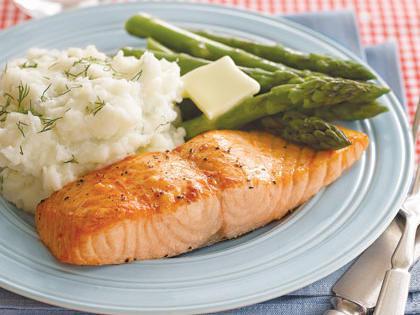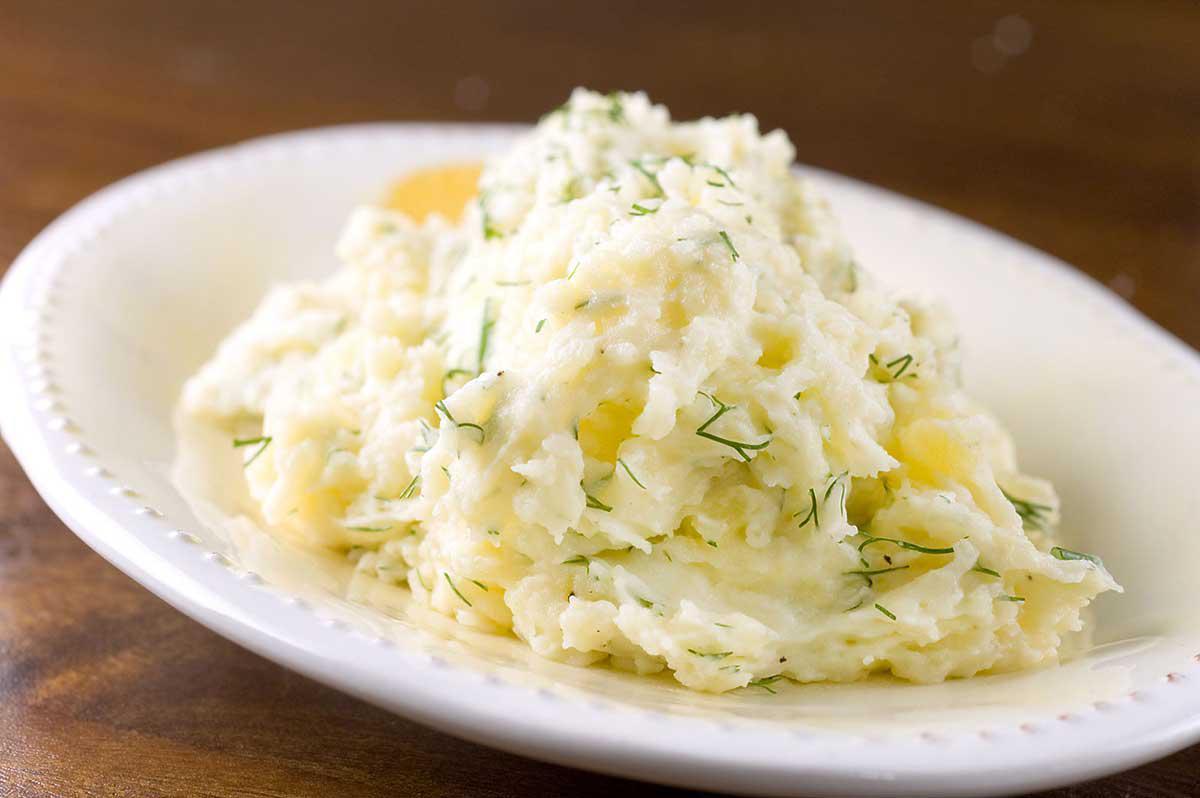The first image is the image on the left, the second image is the image on the right. For the images displayed, is the sentence "In one image, mashed potatoes are served on a plate with a vegetable and a meat or fish course, while a second image shows mashed potatoes with flecks of chive." factually correct? Answer yes or no. Yes. The first image is the image on the left, the second image is the image on the right. Evaluate the accuracy of this statement regarding the images: "There are cut vegetables next to a mashed potato on a plate  in the left image.". Is it true? Answer yes or no. Yes. 